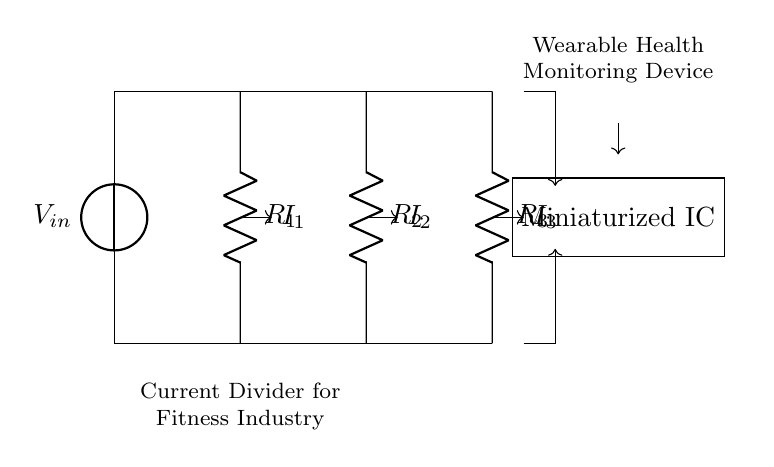What is the input voltage in this circuit? The circuit shows an input voltage source labeled V_in at the top left corner, which indicates the voltage level introduced to the circuit.
Answer: V_in What are the resistor values in the circuit? The circuit diagram lists three resistors: R_1, R_2, and R_3, but does not provide specific numeric values. They represent the resistances in the current divider.
Answer: R_1, R_2, R_3 How many branches are there in this current divider? The current divider consists of three branches (created by R_1, R_2, R_3) that split the input current. Each branch conducts part of the total current, which is typical in current divider circuits.
Answer: Three What is the relationship between input current and branch currents? In a current divider, the input current splits among the branches; the branches' currents (I_1, I_2, I_3) depend on the resistance values. Lower resistance results in a higher current through that branch.
Answer: I_total = I_1 + I_2 + I_3 Which component connects the branches back to the ground? The bottom horizontal line of the circuit connects all the branches back to ground, acting as a common reference point for the current returning from the resistors.
Answer: Ground What is the purpose of this circuit in wearable health monitoring devices? The current divider IC allows for efficient current measurement or distribution, essential for precise data collection in health monitoring. This application allows devices to accurately sense through different branches for physiological signals.
Answer: Current measurement 